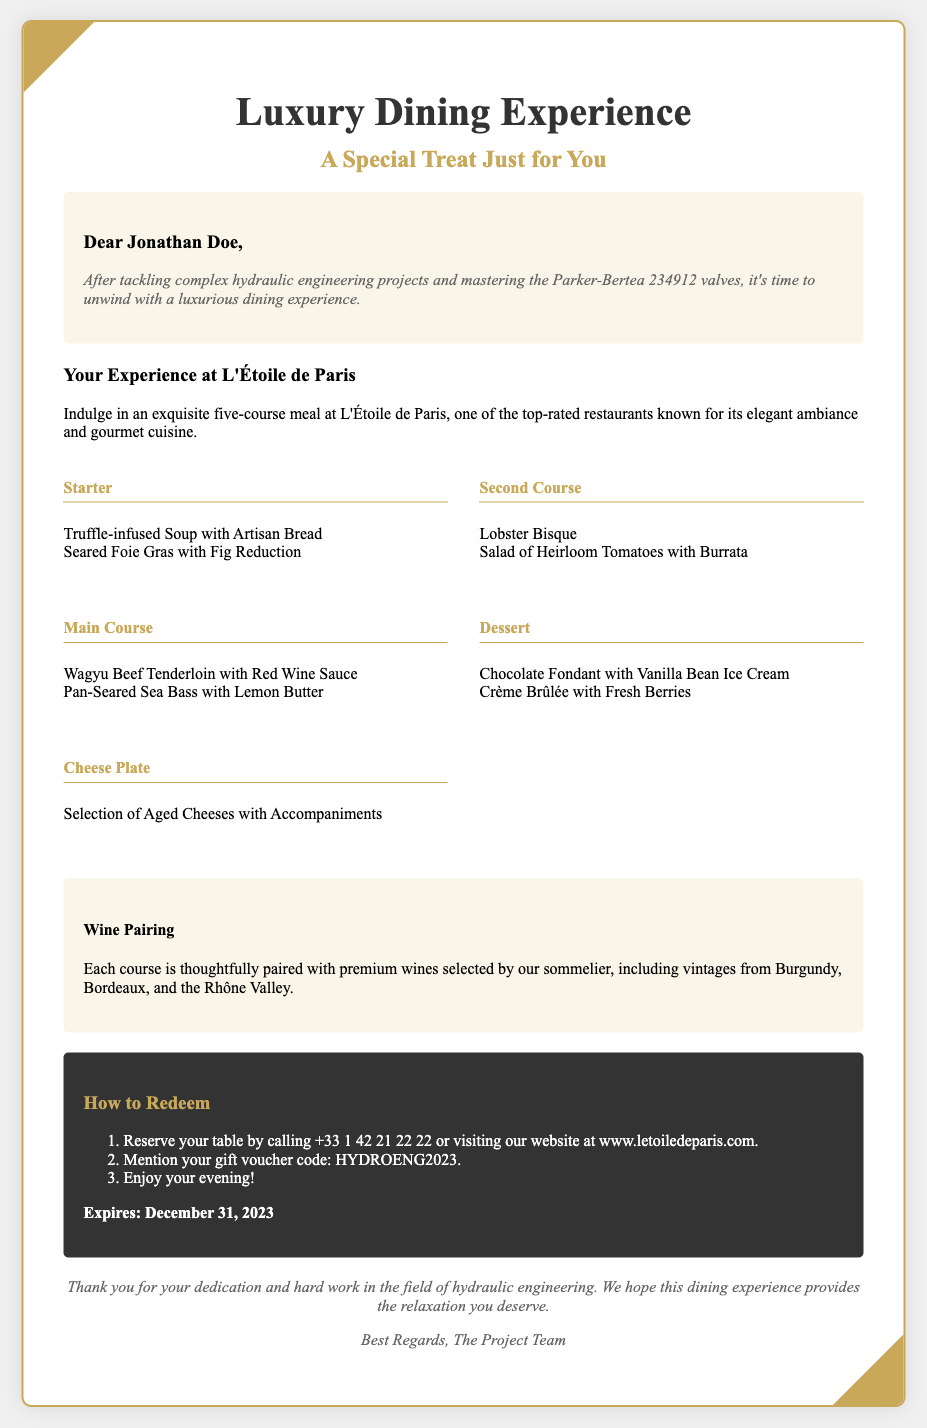What is the name of the restaurant? The name of the restaurant mentioned in the voucher is L'Étoile de Paris.
Answer: L'Étoile de Paris What is the expiration date of the voucher? The expiration date of the gift voucher is stated in the document as December 31, 2023.
Answer: December 31, 2023 What is the gift voucher code? The document specifies the gift voucher code that should be mentioned when redeeming as HYDROENG2023.
Answer: HYDROENG2023 How many courses are included in the meal? The voucher indicates that the meal includes a five-course dining experience.
Answer: Five-course What type of meal is included? The document describes the meal experience as an exquisite five-course meal.
Answer: Exquisite five-course meal What is the theme of the dining experience? The theme of the dining experience is a luxury dining experience.
Answer: Luxury dining experience Which wines are included for pairing? The wine pairing selection includes premium wines from Burgundy, Bordeaux, and the Rhône Valley.
Answer: Burgundy, Bordeaux, Rhône Valley What was Jonathan Doe recognized for? Jonathan Doe is recognized for his dedication and hard work in the field of hydraulic engineering in the document.
Answer: Hydraulic engineering What type of experience does the voucher offer? The voucher offers a personalized dinner experience.
Answer: Personalized dinner experience 